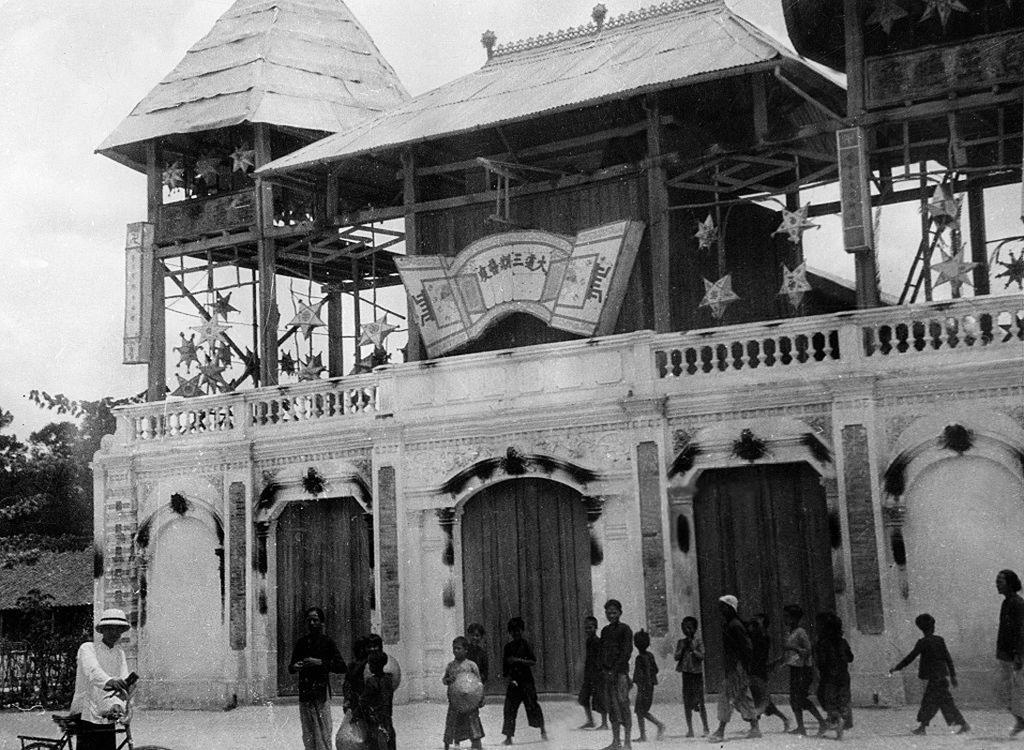Who or what can be seen in the image? There are people in the image. What type of structure is visible in the image? There is a building in the image. What additional objects or features are present in the image? Decorative items and trees are present in the image. What can be seen in the background of the image? The sky is visible in the background of the image. How many snails can be seen crawling on the building in the image? There are no snails present in the image; it only features people, a building, decorative items, trees, and the sky. 